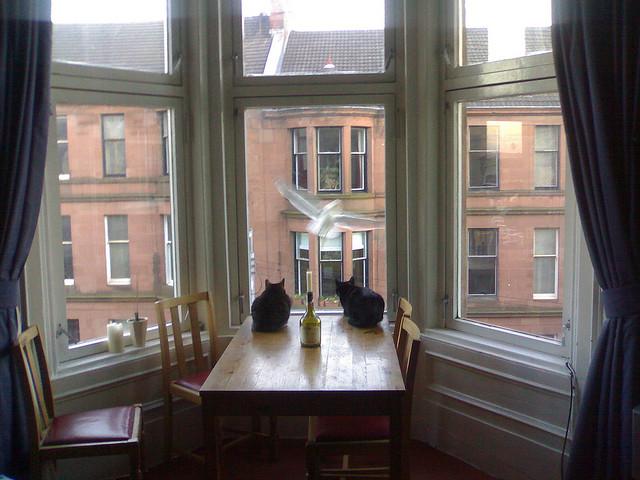How many animals are in this picture?
Be succinct. 2. Is the bird in focus?
Answer briefly. No. Where are the cats sitting?
Concise answer only. Table. 